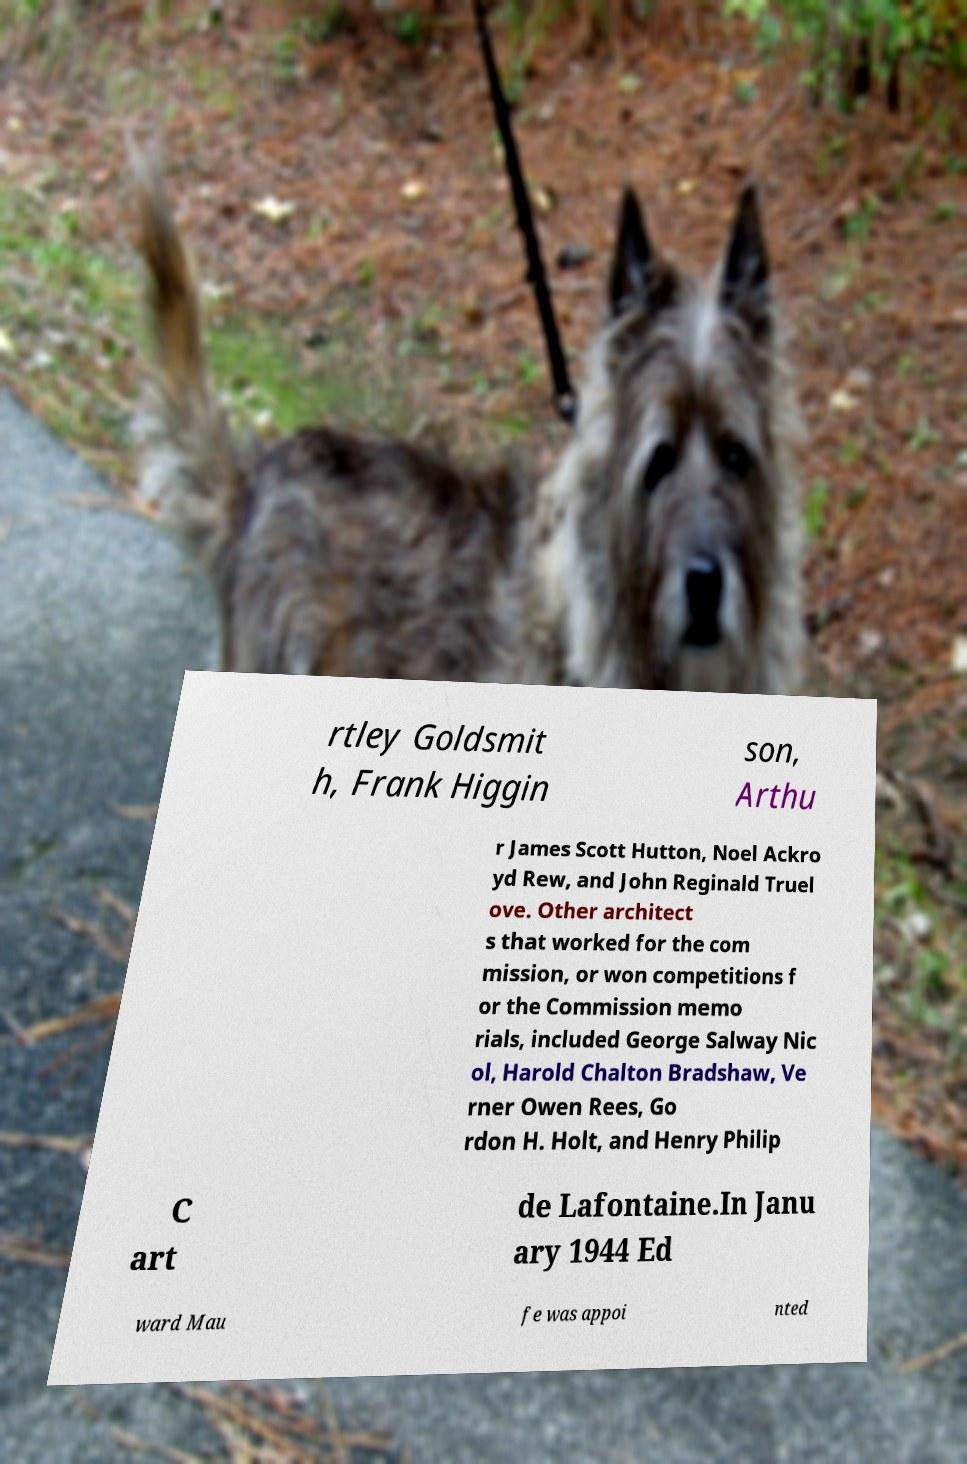I need the written content from this picture converted into text. Can you do that? rtley Goldsmit h, Frank Higgin son, Arthu r James Scott Hutton, Noel Ackro yd Rew, and John Reginald Truel ove. Other architect s that worked for the com mission, or won competitions f or the Commission memo rials, included George Salway Nic ol, Harold Chalton Bradshaw, Ve rner Owen Rees, Go rdon H. Holt, and Henry Philip C art de Lafontaine.In Janu ary 1944 Ed ward Mau fe was appoi nted 